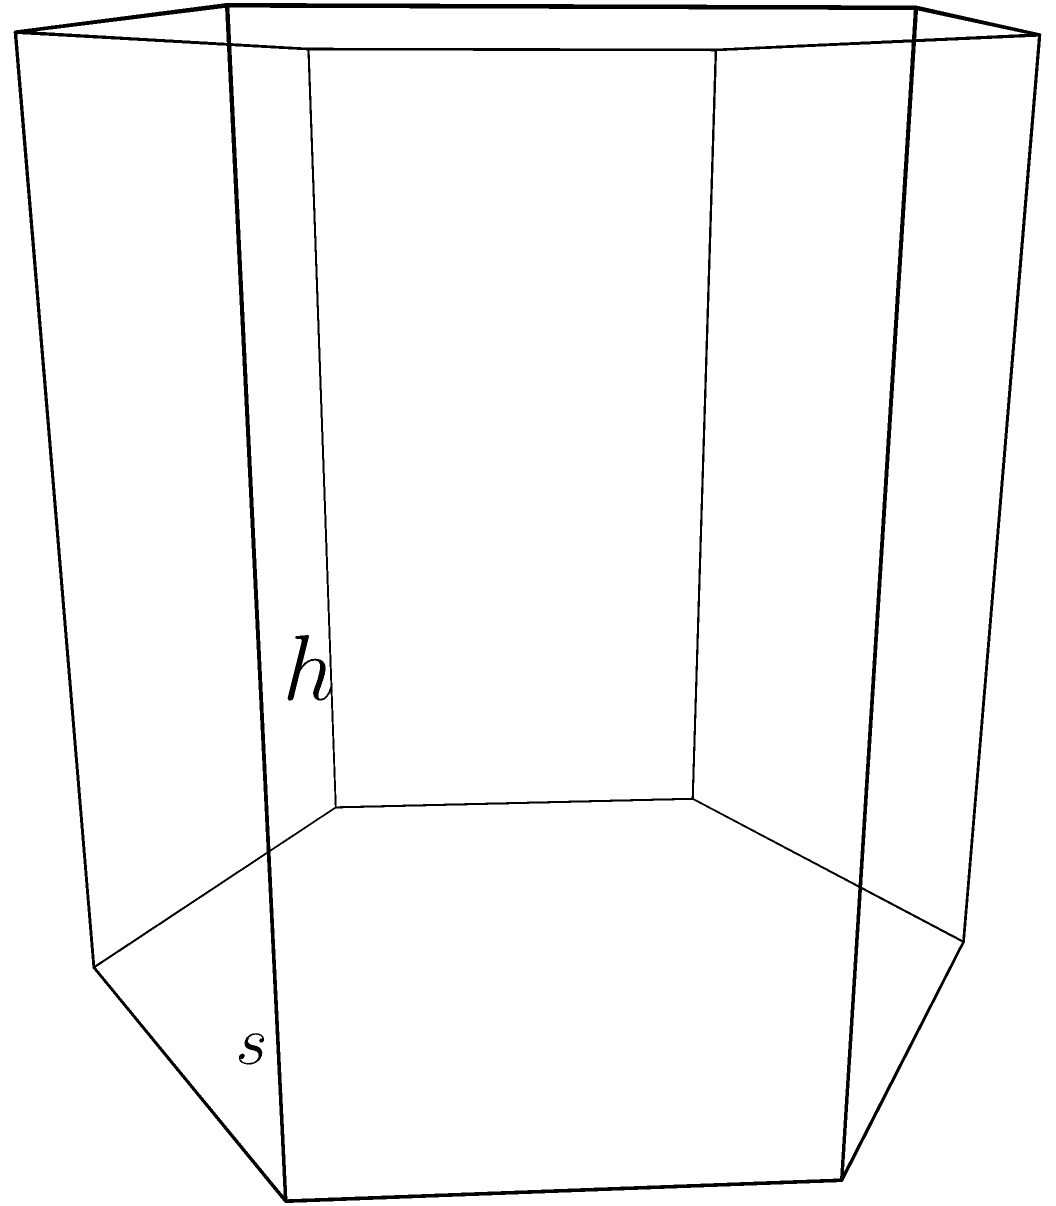In your role as a therapist helping couples through divorce, you often use metaphors to explain complex emotional processes. Consider a regular hexagonal prism as a representation of a relationship's structure. If the side length of the hexagonal base is $s$ and the height of the prism is $h$, what is the lateral surface area of this prism? This area could symbolize the external facets of the relationship that need to be addressed during the divorce process. Let's approach this step-by-step:

1) First, we need to understand what the lateral surface area includes. It's the area of all the rectangular sides of the prism, not including the top and bottom hexagonal bases.

2) A regular hexagon has 6 equal sides. Therefore, the lateral surface of the prism consists of 6 equal rectangles.

3) The width of each rectangle is equal to the side length of the hexagon, $s$.

4) The height of each rectangle is equal to the height of the prism, $h$.

5) The area of one rectangular face is therefore $s \times h$.

6) Since there are 6 such rectangles, we multiply this area by 6.

7) Thus, the lateral surface area is given by the formula:

   $$\text{Lateral Surface Area} = 6sh$$

This formula represents how the external aspects of a relationship (symbolized by $s$) and the duration or depth of the relationship (symbolized by $h$) contribute to the overall complexity of the divorce process.
Answer: $6sh$ 